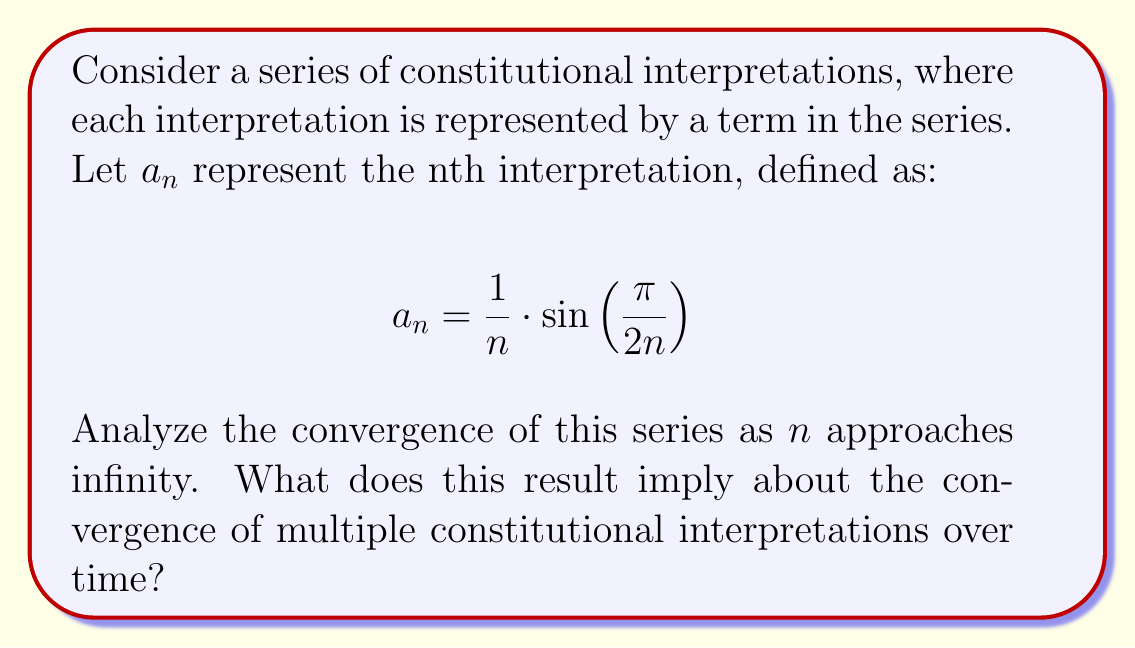Give your solution to this math problem. To analyze the convergence of this series, we need to examine the limit of $a_n$ as $n$ approaches infinity:

1) First, let's consider the limit of $\frac{1}{n}$:
   $$\lim_{n \to \infty} \frac{1}{n} = 0$$

2) Now, let's examine $\sin\left(\frac{\pi}{2n}\right)$:
   As $n$ approaches infinity, $\frac{\pi}{2n}$ approaches 0.
   We know that for small angles $\theta$, $\sin(\theta) \approx \theta$.
   Therefore, $\lim_{n \to \infty} \sin\left(\frac{\pi}{2n}\right) \approx \frac{\pi}{2n}$

3) Combining these results:
   $$\lim_{n \to \infty} a_n = \lim_{n \to \infty} \frac{1}{n} \cdot \sin\left(\frac{\pi}{2n}\right) \approx \lim_{n \to \infty} \frac{1}{n} \cdot \frac{\pi}{2n} = \lim_{n \to \infty} \frac{\pi}{2n^2} = 0$$

4) Since the limit of $a_n$ as $n$ approaches infinity is 0, the series converges to 0.

In the context of constitutional interpretations, this result implies that as the number of interpretations increases over time, their individual impact (represented by the magnitude of each term) diminishes. The convergence to 0 suggests that the collective understanding of the Constitution tends towards a stable point, where additional interpretations have increasingly smaller effects on the overall interpretation.
Answer: The series converges to 0 as $n$ approaches infinity, implying that multiple constitutional interpretations tend to converge towards a stable understanding over time, with each new interpretation having a diminishing impact. 